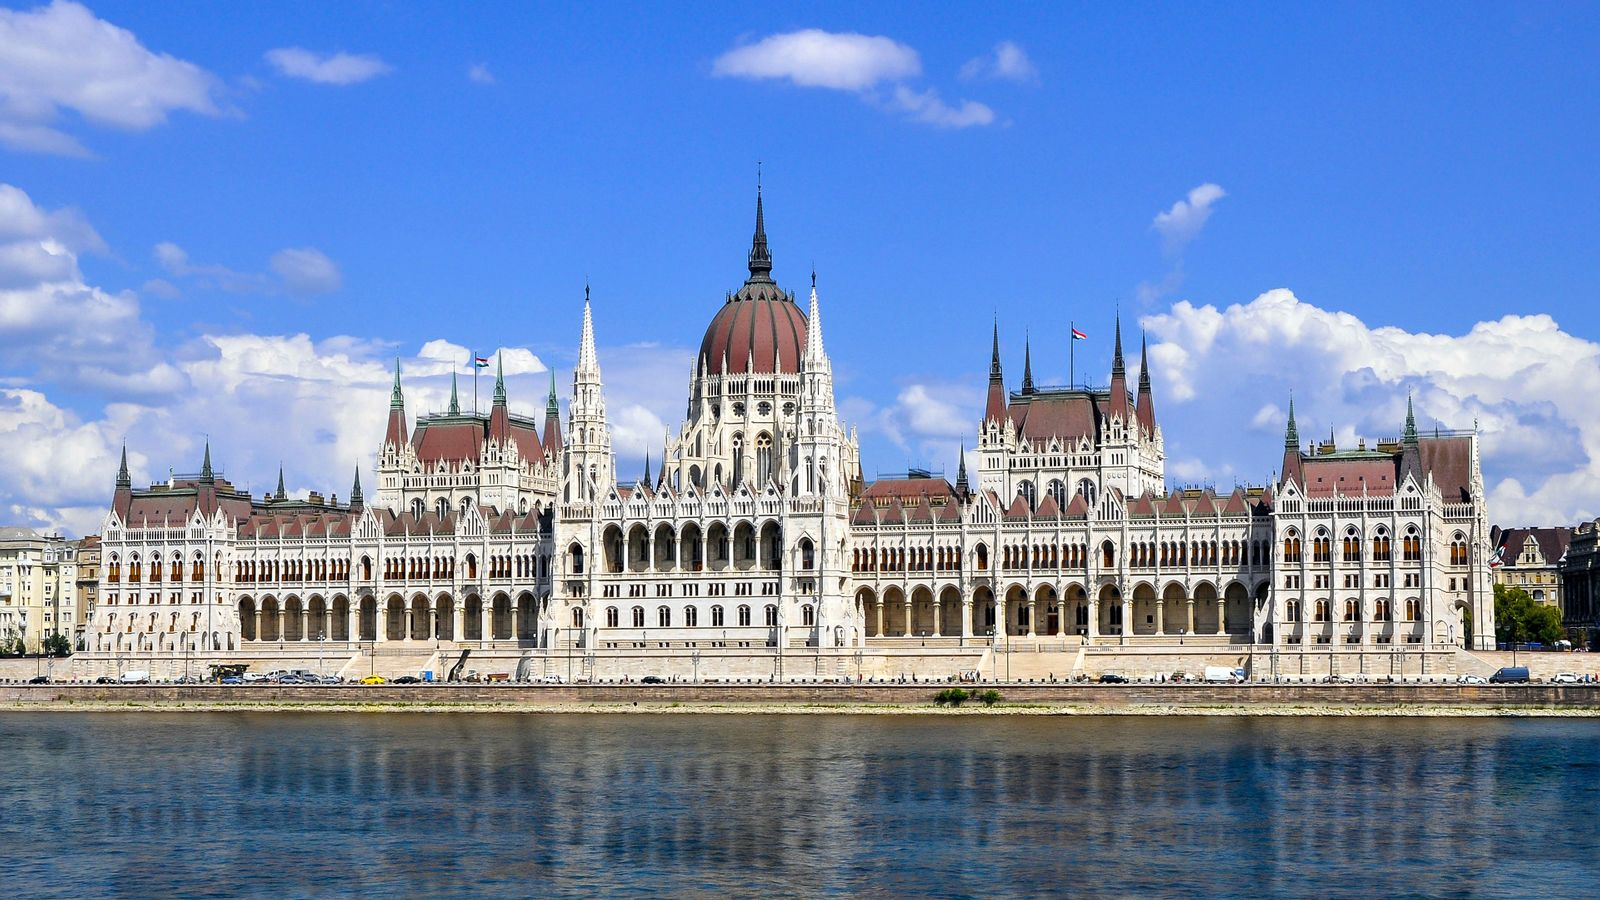What architectural styles are evident in this building? The Hungarian Parliament Building beautifully showcases a blend of Gothic Revival and Renaissance Revival architectural styles. The Gothic Revival elements are evident in the pointed arches, intricate carvings, and numerous spires and pinnacles that adorn the structure. Meanwhile, the Renaissance Revival influence can be seen in the symmetrical layout, grand domes, and the balanced proportions of the building. The facade is embellished with statues of Hungarian leaders, historical figures, and adorned with exquisite craftsmanship, reflecting the artisanal skills of its creators. Together, these styles contribute to the building's majestic and resplendent appearance, making it a remarkable feat of architectural design. 